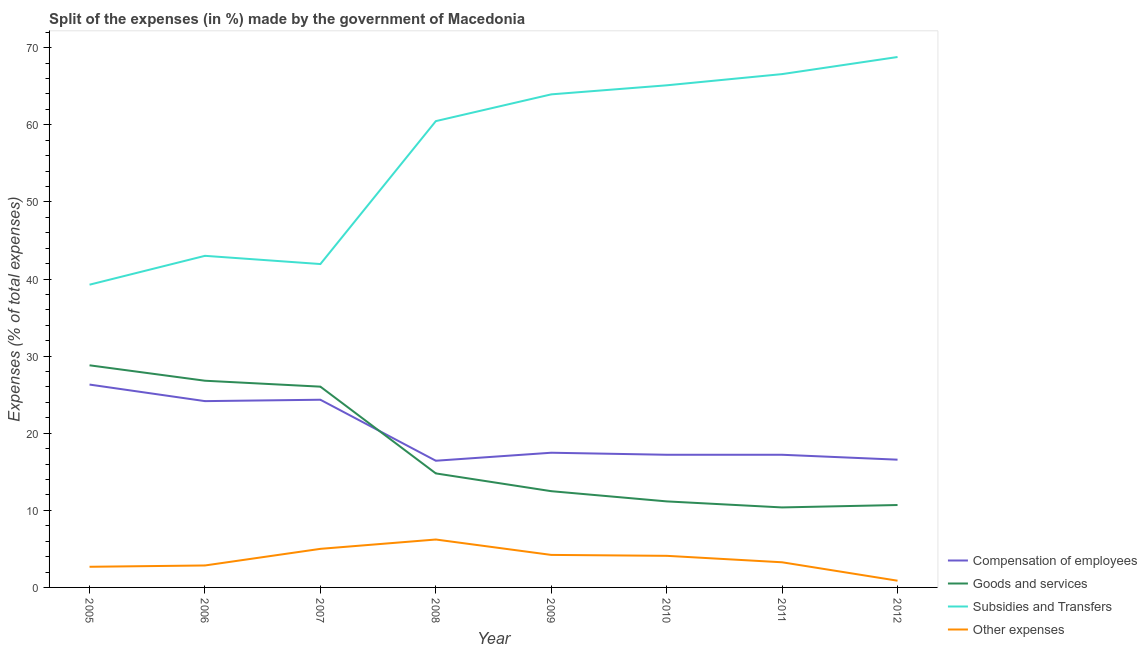How many different coloured lines are there?
Your answer should be very brief. 4. Is the number of lines equal to the number of legend labels?
Keep it short and to the point. Yes. What is the percentage of amount spent on compensation of employees in 2006?
Your answer should be very brief. 24.16. Across all years, what is the maximum percentage of amount spent on goods and services?
Keep it short and to the point. 28.81. Across all years, what is the minimum percentage of amount spent on compensation of employees?
Provide a short and direct response. 16.43. What is the total percentage of amount spent on goods and services in the graph?
Provide a succinct answer. 141.15. What is the difference between the percentage of amount spent on subsidies in 2009 and that in 2011?
Offer a very short reply. -2.63. What is the difference between the percentage of amount spent on compensation of employees in 2007 and the percentage of amount spent on goods and services in 2006?
Offer a terse response. -2.47. What is the average percentage of amount spent on compensation of employees per year?
Offer a very short reply. 19.96. In the year 2008, what is the difference between the percentage of amount spent on goods and services and percentage of amount spent on other expenses?
Give a very brief answer. 8.57. In how many years, is the percentage of amount spent on goods and services greater than 16 %?
Provide a succinct answer. 3. What is the ratio of the percentage of amount spent on subsidies in 2006 to that in 2008?
Your answer should be very brief. 0.71. Is the difference between the percentage of amount spent on goods and services in 2006 and 2012 greater than the difference between the percentage of amount spent on compensation of employees in 2006 and 2012?
Make the answer very short. Yes. What is the difference between the highest and the second highest percentage of amount spent on compensation of employees?
Give a very brief answer. 1.97. What is the difference between the highest and the lowest percentage of amount spent on compensation of employees?
Your answer should be compact. 9.88. Is the sum of the percentage of amount spent on other expenses in 2007 and 2008 greater than the maximum percentage of amount spent on goods and services across all years?
Offer a terse response. No. Is the percentage of amount spent on subsidies strictly less than the percentage of amount spent on goods and services over the years?
Your response must be concise. No. How many years are there in the graph?
Make the answer very short. 8. Are the values on the major ticks of Y-axis written in scientific E-notation?
Make the answer very short. No. Does the graph contain any zero values?
Offer a terse response. No. Does the graph contain grids?
Give a very brief answer. No. How many legend labels are there?
Provide a succinct answer. 4. How are the legend labels stacked?
Provide a short and direct response. Vertical. What is the title of the graph?
Provide a succinct answer. Split of the expenses (in %) made by the government of Macedonia. What is the label or title of the Y-axis?
Keep it short and to the point. Expenses (% of total expenses). What is the Expenses (% of total expenses) of Compensation of employees in 2005?
Your answer should be compact. 26.31. What is the Expenses (% of total expenses) of Goods and services in 2005?
Offer a very short reply. 28.81. What is the Expenses (% of total expenses) of Subsidies and Transfers in 2005?
Your answer should be compact. 39.27. What is the Expenses (% of total expenses) of Other expenses in 2005?
Offer a very short reply. 2.68. What is the Expenses (% of total expenses) of Compensation of employees in 2006?
Provide a succinct answer. 24.16. What is the Expenses (% of total expenses) in Goods and services in 2006?
Give a very brief answer. 26.81. What is the Expenses (% of total expenses) of Subsidies and Transfers in 2006?
Provide a succinct answer. 43.01. What is the Expenses (% of total expenses) in Other expenses in 2006?
Offer a terse response. 2.85. What is the Expenses (% of total expenses) of Compensation of employees in 2007?
Make the answer very short. 24.34. What is the Expenses (% of total expenses) of Goods and services in 2007?
Provide a short and direct response. 26.04. What is the Expenses (% of total expenses) in Subsidies and Transfers in 2007?
Offer a very short reply. 41.94. What is the Expenses (% of total expenses) of Other expenses in 2007?
Offer a very short reply. 5. What is the Expenses (% of total expenses) in Compensation of employees in 2008?
Your response must be concise. 16.43. What is the Expenses (% of total expenses) in Goods and services in 2008?
Your response must be concise. 14.79. What is the Expenses (% of total expenses) in Subsidies and Transfers in 2008?
Your answer should be compact. 60.48. What is the Expenses (% of total expenses) in Other expenses in 2008?
Offer a terse response. 6.21. What is the Expenses (% of total expenses) of Compensation of employees in 2009?
Ensure brevity in your answer.  17.47. What is the Expenses (% of total expenses) in Goods and services in 2009?
Ensure brevity in your answer.  12.48. What is the Expenses (% of total expenses) of Subsidies and Transfers in 2009?
Give a very brief answer. 63.95. What is the Expenses (% of total expenses) in Other expenses in 2009?
Ensure brevity in your answer.  4.22. What is the Expenses (% of total expenses) of Compensation of employees in 2010?
Keep it short and to the point. 17.21. What is the Expenses (% of total expenses) in Goods and services in 2010?
Offer a terse response. 11.16. What is the Expenses (% of total expenses) in Subsidies and Transfers in 2010?
Your answer should be compact. 65.12. What is the Expenses (% of total expenses) of Other expenses in 2010?
Make the answer very short. 4.1. What is the Expenses (% of total expenses) in Compensation of employees in 2011?
Keep it short and to the point. 17.21. What is the Expenses (% of total expenses) in Goods and services in 2011?
Offer a terse response. 10.38. What is the Expenses (% of total expenses) in Subsidies and Transfers in 2011?
Provide a short and direct response. 66.58. What is the Expenses (% of total expenses) in Other expenses in 2011?
Your answer should be very brief. 3.26. What is the Expenses (% of total expenses) in Compensation of employees in 2012?
Your answer should be very brief. 16.57. What is the Expenses (% of total expenses) of Goods and services in 2012?
Give a very brief answer. 10.69. What is the Expenses (% of total expenses) of Subsidies and Transfers in 2012?
Your answer should be very brief. 68.79. What is the Expenses (% of total expenses) of Other expenses in 2012?
Provide a succinct answer. 0.87. Across all years, what is the maximum Expenses (% of total expenses) in Compensation of employees?
Your answer should be compact. 26.31. Across all years, what is the maximum Expenses (% of total expenses) in Goods and services?
Offer a terse response. 28.81. Across all years, what is the maximum Expenses (% of total expenses) in Subsidies and Transfers?
Keep it short and to the point. 68.79. Across all years, what is the maximum Expenses (% of total expenses) in Other expenses?
Your answer should be very brief. 6.21. Across all years, what is the minimum Expenses (% of total expenses) in Compensation of employees?
Provide a succinct answer. 16.43. Across all years, what is the minimum Expenses (% of total expenses) of Goods and services?
Keep it short and to the point. 10.38. Across all years, what is the minimum Expenses (% of total expenses) of Subsidies and Transfers?
Your answer should be very brief. 39.27. Across all years, what is the minimum Expenses (% of total expenses) of Other expenses?
Give a very brief answer. 0.87. What is the total Expenses (% of total expenses) of Compensation of employees in the graph?
Your answer should be compact. 159.7. What is the total Expenses (% of total expenses) of Goods and services in the graph?
Offer a terse response. 141.15. What is the total Expenses (% of total expenses) in Subsidies and Transfers in the graph?
Your answer should be compact. 449.14. What is the total Expenses (% of total expenses) in Other expenses in the graph?
Provide a succinct answer. 29.19. What is the difference between the Expenses (% of total expenses) of Compensation of employees in 2005 and that in 2006?
Your response must be concise. 2.15. What is the difference between the Expenses (% of total expenses) in Goods and services in 2005 and that in 2006?
Your response must be concise. 2. What is the difference between the Expenses (% of total expenses) of Subsidies and Transfers in 2005 and that in 2006?
Provide a short and direct response. -3.74. What is the difference between the Expenses (% of total expenses) of Other expenses in 2005 and that in 2006?
Give a very brief answer. -0.17. What is the difference between the Expenses (% of total expenses) in Compensation of employees in 2005 and that in 2007?
Offer a very short reply. 1.97. What is the difference between the Expenses (% of total expenses) of Goods and services in 2005 and that in 2007?
Make the answer very short. 2.77. What is the difference between the Expenses (% of total expenses) in Subsidies and Transfers in 2005 and that in 2007?
Make the answer very short. -2.68. What is the difference between the Expenses (% of total expenses) of Other expenses in 2005 and that in 2007?
Give a very brief answer. -2.33. What is the difference between the Expenses (% of total expenses) in Compensation of employees in 2005 and that in 2008?
Make the answer very short. 9.88. What is the difference between the Expenses (% of total expenses) of Goods and services in 2005 and that in 2008?
Provide a short and direct response. 14.02. What is the difference between the Expenses (% of total expenses) in Subsidies and Transfers in 2005 and that in 2008?
Your answer should be very brief. -21.21. What is the difference between the Expenses (% of total expenses) of Other expenses in 2005 and that in 2008?
Offer a very short reply. -3.54. What is the difference between the Expenses (% of total expenses) of Compensation of employees in 2005 and that in 2009?
Keep it short and to the point. 8.84. What is the difference between the Expenses (% of total expenses) in Goods and services in 2005 and that in 2009?
Offer a very short reply. 16.33. What is the difference between the Expenses (% of total expenses) of Subsidies and Transfers in 2005 and that in 2009?
Ensure brevity in your answer.  -24.68. What is the difference between the Expenses (% of total expenses) of Other expenses in 2005 and that in 2009?
Offer a terse response. -1.54. What is the difference between the Expenses (% of total expenses) of Compensation of employees in 2005 and that in 2010?
Your response must be concise. 9.1. What is the difference between the Expenses (% of total expenses) of Goods and services in 2005 and that in 2010?
Keep it short and to the point. 17.65. What is the difference between the Expenses (% of total expenses) in Subsidies and Transfers in 2005 and that in 2010?
Your response must be concise. -25.86. What is the difference between the Expenses (% of total expenses) in Other expenses in 2005 and that in 2010?
Give a very brief answer. -1.42. What is the difference between the Expenses (% of total expenses) in Compensation of employees in 2005 and that in 2011?
Your answer should be very brief. 9.1. What is the difference between the Expenses (% of total expenses) of Goods and services in 2005 and that in 2011?
Provide a short and direct response. 18.43. What is the difference between the Expenses (% of total expenses) in Subsidies and Transfers in 2005 and that in 2011?
Keep it short and to the point. -27.31. What is the difference between the Expenses (% of total expenses) in Other expenses in 2005 and that in 2011?
Keep it short and to the point. -0.58. What is the difference between the Expenses (% of total expenses) in Compensation of employees in 2005 and that in 2012?
Ensure brevity in your answer.  9.74. What is the difference between the Expenses (% of total expenses) in Goods and services in 2005 and that in 2012?
Give a very brief answer. 18.12. What is the difference between the Expenses (% of total expenses) of Subsidies and Transfers in 2005 and that in 2012?
Offer a terse response. -29.53. What is the difference between the Expenses (% of total expenses) of Other expenses in 2005 and that in 2012?
Keep it short and to the point. 1.8. What is the difference between the Expenses (% of total expenses) in Compensation of employees in 2006 and that in 2007?
Give a very brief answer. -0.18. What is the difference between the Expenses (% of total expenses) of Goods and services in 2006 and that in 2007?
Your answer should be very brief. 0.77. What is the difference between the Expenses (% of total expenses) of Subsidies and Transfers in 2006 and that in 2007?
Your answer should be compact. 1.07. What is the difference between the Expenses (% of total expenses) of Other expenses in 2006 and that in 2007?
Make the answer very short. -2.16. What is the difference between the Expenses (% of total expenses) of Compensation of employees in 2006 and that in 2008?
Provide a short and direct response. 7.73. What is the difference between the Expenses (% of total expenses) of Goods and services in 2006 and that in 2008?
Ensure brevity in your answer.  12.02. What is the difference between the Expenses (% of total expenses) of Subsidies and Transfers in 2006 and that in 2008?
Make the answer very short. -17.47. What is the difference between the Expenses (% of total expenses) of Other expenses in 2006 and that in 2008?
Keep it short and to the point. -3.37. What is the difference between the Expenses (% of total expenses) in Compensation of employees in 2006 and that in 2009?
Ensure brevity in your answer.  6.69. What is the difference between the Expenses (% of total expenses) in Goods and services in 2006 and that in 2009?
Provide a succinct answer. 14.33. What is the difference between the Expenses (% of total expenses) in Subsidies and Transfers in 2006 and that in 2009?
Offer a very short reply. -20.94. What is the difference between the Expenses (% of total expenses) of Other expenses in 2006 and that in 2009?
Ensure brevity in your answer.  -1.37. What is the difference between the Expenses (% of total expenses) in Compensation of employees in 2006 and that in 2010?
Give a very brief answer. 6.96. What is the difference between the Expenses (% of total expenses) of Goods and services in 2006 and that in 2010?
Make the answer very short. 15.65. What is the difference between the Expenses (% of total expenses) of Subsidies and Transfers in 2006 and that in 2010?
Give a very brief answer. -22.11. What is the difference between the Expenses (% of total expenses) of Other expenses in 2006 and that in 2010?
Your response must be concise. -1.25. What is the difference between the Expenses (% of total expenses) in Compensation of employees in 2006 and that in 2011?
Provide a succinct answer. 6.96. What is the difference between the Expenses (% of total expenses) in Goods and services in 2006 and that in 2011?
Give a very brief answer. 16.43. What is the difference between the Expenses (% of total expenses) of Subsidies and Transfers in 2006 and that in 2011?
Provide a succinct answer. -23.57. What is the difference between the Expenses (% of total expenses) in Other expenses in 2006 and that in 2011?
Offer a very short reply. -0.41. What is the difference between the Expenses (% of total expenses) of Compensation of employees in 2006 and that in 2012?
Your answer should be compact. 7.59. What is the difference between the Expenses (% of total expenses) in Goods and services in 2006 and that in 2012?
Provide a succinct answer. 16.12. What is the difference between the Expenses (% of total expenses) of Subsidies and Transfers in 2006 and that in 2012?
Keep it short and to the point. -25.79. What is the difference between the Expenses (% of total expenses) in Other expenses in 2006 and that in 2012?
Your response must be concise. 1.98. What is the difference between the Expenses (% of total expenses) in Compensation of employees in 2007 and that in 2008?
Provide a short and direct response. 7.91. What is the difference between the Expenses (% of total expenses) in Goods and services in 2007 and that in 2008?
Give a very brief answer. 11.25. What is the difference between the Expenses (% of total expenses) of Subsidies and Transfers in 2007 and that in 2008?
Keep it short and to the point. -18.54. What is the difference between the Expenses (% of total expenses) in Other expenses in 2007 and that in 2008?
Keep it short and to the point. -1.21. What is the difference between the Expenses (% of total expenses) in Compensation of employees in 2007 and that in 2009?
Keep it short and to the point. 6.87. What is the difference between the Expenses (% of total expenses) of Goods and services in 2007 and that in 2009?
Provide a succinct answer. 13.56. What is the difference between the Expenses (% of total expenses) in Subsidies and Transfers in 2007 and that in 2009?
Offer a very short reply. -22.01. What is the difference between the Expenses (% of total expenses) of Other expenses in 2007 and that in 2009?
Provide a short and direct response. 0.79. What is the difference between the Expenses (% of total expenses) in Compensation of employees in 2007 and that in 2010?
Your answer should be very brief. 7.14. What is the difference between the Expenses (% of total expenses) in Goods and services in 2007 and that in 2010?
Your answer should be very brief. 14.88. What is the difference between the Expenses (% of total expenses) in Subsidies and Transfers in 2007 and that in 2010?
Ensure brevity in your answer.  -23.18. What is the difference between the Expenses (% of total expenses) in Other expenses in 2007 and that in 2010?
Keep it short and to the point. 0.9. What is the difference between the Expenses (% of total expenses) of Compensation of employees in 2007 and that in 2011?
Keep it short and to the point. 7.14. What is the difference between the Expenses (% of total expenses) of Goods and services in 2007 and that in 2011?
Provide a short and direct response. 15.66. What is the difference between the Expenses (% of total expenses) in Subsidies and Transfers in 2007 and that in 2011?
Give a very brief answer. -24.63. What is the difference between the Expenses (% of total expenses) of Other expenses in 2007 and that in 2011?
Provide a short and direct response. 1.74. What is the difference between the Expenses (% of total expenses) of Compensation of employees in 2007 and that in 2012?
Make the answer very short. 7.77. What is the difference between the Expenses (% of total expenses) in Goods and services in 2007 and that in 2012?
Offer a very short reply. 15.35. What is the difference between the Expenses (% of total expenses) of Subsidies and Transfers in 2007 and that in 2012?
Provide a short and direct response. -26.85. What is the difference between the Expenses (% of total expenses) in Other expenses in 2007 and that in 2012?
Provide a succinct answer. 4.13. What is the difference between the Expenses (% of total expenses) in Compensation of employees in 2008 and that in 2009?
Your answer should be compact. -1.04. What is the difference between the Expenses (% of total expenses) of Goods and services in 2008 and that in 2009?
Your answer should be compact. 2.31. What is the difference between the Expenses (% of total expenses) in Subsidies and Transfers in 2008 and that in 2009?
Give a very brief answer. -3.47. What is the difference between the Expenses (% of total expenses) in Other expenses in 2008 and that in 2009?
Offer a terse response. 2. What is the difference between the Expenses (% of total expenses) of Compensation of employees in 2008 and that in 2010?
Ensure brevity in your answer.  -0.78. What is the difference between the Expenses (% of total expenses) of Goods and services in 2008 and that in 2010?
Offer a very short reply. 3.63. What is the difference between the Expenses (% of total expenses) of Subsidies and Transfers in 2008 and that in 2010?
Your answer should be compact. -4.64. What is the difference between the Expenses (% of total expenses) in Other expenses in 2008 and that in 2010?
Give a very brief answer. 2.12. What is the difference between the Expenses (% of total expenses) of Compensation of employees in 2008 and that in 2011?
Your answer should be compact. -0.77. What is the difference between the Expenses (% of total expenses) in Goods and services in 2008 and that in 2011?
Give a very brief answer. 4.41. What is the difference between the Expenses (% of total expenses) of Subsidies and Transfers in 2008 and that in 2011?
Make the answer very short. -6.1. What is the difference between the Expenses (% of total expenses) in Other expenses in 2008 and that in 2011?
Give a very brief answer. 2.95. What is the difference between the Expenses (% of total expenses) of Compensation of employees in 2008 and that in 2012?
Offer a very short reply. -0.14. What is the difference between the Expenses (% of total expenses) of Goods and services in 2008 and that in 2012?
Ensure brevity in your answer.  4.1. What is the difference between the Expenses (% of total expenses) in Subsidies and Transfers in 2008 and that in 2012?
Offer a terse response. -8.32. What is the difference between the Expenses (% of total expenses) in Other expenses in 2008 and that in 2012?
Your response must be concise. 5.34. What is the difference between the Expenses (% of total expenses) of Compensation of employees in 2009 and that in 2010?
Your answer should be compact. 0.26. What is the difference between the Expenses (% of total expenses) of Goods and services in 2009 and that in 2010?
Your response must be concise. 1.32. What is the difference between the Expenses (% of total expenses) in Subsidies and Transfers in 2009 and that in 2010?
Make the answer very short. -1.17. What is the difference between the Expenses (% of total expenses) in Other expenses in 2009 and that in 2010?
Give a very brief answer. 0.12. What is the difference between the Expenses (% of total expenses) in Compensation of employees in 2009 and that in 2011?
Ensure brevity in your answer.  0.26. What is the difference between the Expenses (% of total expenses) of Goods and services in 2009 and that in 2011?
Offer a very short reply. 2.11. What is the difference between the Expenses (% of total expenses) of Subsidies and Transfers in 2009 and that in 2011?
Offer a very short reply. -2.63. What is the difference between the Expenses (% of total expenses) in Other expenses in 2009 and that in 2011?
Offer a terse response. 0.96. What is the difference between the Expenses (% of total expenses) of Compensation of employees in 2009 and that in 2012?
Ensure brevity in your answer.  0.9. What is the difference between the Expenses (% of total expenses) of Goods and services in 2009 and that in 2012?
Make the answer very short. 1.79. What is the difference between the Expenses (% of total expenses) in Subsidies and Transfers in 2009 and that in 2012?
Offer a very short reply. -4.84. What is the difference between the Expenses (% of total expenses) of Other expenses in 2009 and that in 2012?
Your answer should be compact. 3.34. What is the difference between the Expenses (% of total expenses) in Compensation of employees in 2010 and that in 2011?
Provide a succinct answer. 0. What is the difference between the Expenses (% of total expenses) of Goods and services in 2010 and that in 2011?
Provide a succinct answer. 0.78. What is the difference between the Expenses (% of total expenses) in Subsidies and Transfers in 2010 and that in 2011?
Make the answer very short. -1.45. What is the difference between the Expenses (% of total expenses) in Other expenses in 2010 and that in 2011?
Your answer should be compact. 0.84. What is the difference between the Expenses (% of total expenses) of Compensation of employees in 2010 and that in 2012?
Keep it short and to the point. 0.64. What is the difference between the Expenses (% of total expenses) in Goods and services in 2010 and that in 2012?
Ensure brevity in your answer.  0.47. What is the difference between the Expenses (% of total expenses) of Subsidies and Transfers in 2010 and that in 2012?
Your answer should be compact. -3.67. What is the difference between the Expenses (% of total expenses) in Other expenses in 2010 and that in 2012?
Offer a very short reply. 3.23. What is the difference between the Expenses (% of total expenses) in Compensation of employees in 2011 and that in 2012?
Your answer should be very brief. 0.64. What is the difference between the Expenses (% of total expenses) in Goods and services in 2011 and that in 2012?
Your response must be concise. -0.31. What is the difference between the Expenses (% of total expenses) of Subsidies and Transfers in 2011 and that in 2012?
Ensure brevity in your answer.  -2.22. What is the difference between the Expenses (% of total expenses) of Other expenses in 2011 and that in 2012?
Offer a terse response. 2.39. What is the difference between the Expenses (% of total expenses) in Compensation of employees in 2005 and the Expenses (% of total expenses) in Goods and services in 2006?
Give a very brief answer. -0.5. What is the difference between the Expenses (% of total expenses) of Compensation of employees in 2005 and the Expenses (% of total expenses) of Subsidies and Transfers in 2006?
Offer a terse response. -16.7. What is the difference between the Expenses (% of total expenses) of Compensation of employees in 2005 and the Expenses (% of total expenses) of Other expenses in 2006?
Give a very brief answer. 23.46. What is the difference between the Expenses (% of total expenses) in Goods and services in 2005 and the Expenses (% of total expenses) in Subsidies and Transfers in 2006?
Make the answer very short. -14.2. What is the difference between the Expenses (% of total expenses) in Goods and services in 2005 and the Expenses (% of total expenses) in Other expenses in 2006?
Make the answer very short. 25.96. What is the difference between the Expenses (% of total expenses) of Subsidies and Transfers in 2005 and the Expenses (% of total expenses) of Other expenses in 2006?
Your answer should be very brief. 36.42. What is the difference between the Expenses (% of total expenses) of Compensation of employees in 2005 and the Expenses (% of total expenses) of Goods and services in 2007?
Your answer should be compact. 0.27. What is the difference between the Expenses (% of total expenses) in Compensation of employees in 2005 and the Expenses (% of total expenses) in Subsidies and Transfers in 2007?
Your answer should be compact. -15.63. What is the difference between the Expenses (% of total expenses) in Compensation of employees in 2005 and the Expenses (% of total expenses) in Other expenses in 2007?
Provide a short and direct response. 21.31. What is the difference between the Expenses (% of total expenses) in Goods and services in 2005 and the Expenses (% of total expenses) in Subsidies and Transfers in 2007?
Offer a very short reply. -13.13. What is the difference between the Expenses (% of total expenses) in Goods and services in 2005 and the Expenses (% of total expenses) in Other expenses in 2007?
Keep it short and to the point. 23.8. What is the difference between the Expenses (% of total expenses) of Subsidies and Transfers in 2005 and the Expenses (% of total expenses) of Other expenses in 2007?
Offer a very short reply. 34.26. What is the difference between the Expenses (% of total expenses) in Compensation of employees in 2005 and the Expenses (% of total expenses) in Goods and services in 2008?
Keep it short and to the point. 11.52. What is the difference between the Expenses (% of total expenses) of Compensation of employees in 2005 and the Expenses (% of total expenses) of Subsidies and Transfers in 2008?
Provide a short and direct response. -34.17. What is the difference between the Expenses (% of total expenses) in Compensation of employees in 2005 and the Expenses (% of total expenses) in Other expenses in 2008?
Your answer should be very brief. 20.1. What is the difference between the Expenses (% of total expenses) in Goods and services in 2005 and the Expenses (% of total expenses) in Subsidies and Transfers in 2008?
Ensure brevity in your answer.  -31.67. What is the difference between the Expenses (% of total expenses) in Goods and services in 2005 and the Expenses (% of total expenses) in Other expenses in 2008?
Provide a short and direct response. 22.59. What is the difference between the Expenses (% of total expenses) of Subsidies and Transfers in 2005 and the Expenses (% of total expenses) of Other expenses in 2008?
Your response must be concise. 33.05. What is the difference between the Expenses (% of total expenses) of Compensation of employees in 2005 and the Expenses (% of total expenses) of Goods and services in 2009?
Provide a short and direct response. 13.83. What is the difference between the Expenses (% of total expenses) in Compensation of employees in 2005 and the Expenses (% of total expenses) in Subsidies and Transfers in 2009?
Make the answer very short. -37.64. What is the difference between the Expenses (% of total expenses) in Compensation of employees in 2005 and the Expenses (% of total expenses) in Other expenses in 2009?
Make the answer very short. 22.09. What is the difference between the Expenses (% of total expenses) in Goods and services in 2005 and the Expenses (% of total expenses) in Subsidies and Transfers in 2009?
Offer a terse response. -35.14. What is the difference between the Expenses (% of total expenses) of Goods and services in 2005 and the Expenses (% of total expenses) of Other expenses in 2009?
Your answer should be very brief. 24.59. What is the difference between the Expenses (% of total expenses) of Subsidies and Transfers in 2005 and the Expenses (% of total expenses) of Other expenses in 2009?
Provide a short and direct response. 35.05. What is the difference between the Expenses (% of total expenses) of Compensation of employees in 2005 and the Expenses (% of total expenses) of Goods and services in 2010?
Your response must be concise. 15.15. What is the difference between the Expenses (% of total expenses) of Compensation of employees in 2005 and the Expenses (% of total expenses) of Subsidies and Transfers in 2010?
Make the answer very short. -38.81. What is the difference between the Expenses (% of total expenses) of Compensation of employees in 2005 and the Expenses (% of total expenses) of Other expenses in 2010?
Ensure brevity in your answer.  22.21. What is the difference between the Expenses (% of total expenses) of Goods and services in 2005 and the Expenses (% of total expenses) of Subsidies and Transfers in 2010?
Make the answer very short. -36.31. What is the difference between the Expenses (% of total expenses) of Goods and services in 2005 and the Expenses (% of total expenses) of Other expenses in 2010?
Your response must be concise. 24.71. What is the difference between the Expenses (% of total expenses) of Subsidies and Transfers in 2005 and the Expenses (% of total expenses) of Other expenses in 2010?
Give a very brief answer. 35.17. What is the difference between the Expenses (% of total expenses) in Compensation of employees in 2005 and the Expenses (% of total expenses) in Goods and services in 2011?
Your response must be concise. 15.93. What is the difference between the Expenses (% of total expenses) in Compensation of employees in 2005 and the Expenses (% of total expenses) in Subsidies and Transfers in 2011?
Provide a short and direct response. -40.27. What is the difference between the Expenses (% of total expenses) in Compensation of employees in 2005 and the Expenses (% of total expenses) in Other expenses in 2011?
Keep it short and to the point. 23.05. What is the difference between the Expenses (% of total expenses) in Goods and services in 2005 and the Expenses (% of total expenses) in Subsidies and Transfers in 2011?
Ensure brevity in your answer.  -37.77. What is the difference between the Expenses (% of total expenses) in Goods and services in 2005 and the Expenses (% of total expenses) in Other expenses in 2011?
Your answer should be compact. 25.55. What is the difference between the Expenses (% of total expenses) in Subsidies and Transfers in 2005 and the Expenses (% of total expenses) in Other expenses in 2011?
Your answer should be very brief. 36. What is the difference between the Expenses (% of total expenses) of Compensation of employees in 2005 and the Expenses (% of total expenses) of Goods and services in 2012?
Your response must be concise. 15.62. What is the difference between the Expenses (% of total expenses) of Compensation of employees in 2005 and the Expenses (% of total expenses) of Subsidies and Transfers in 2012?
Your answer should be compact. -42.48. What is the difference between the Expenses (% of total expenses) in Compensation of employees in 2005 and the Expenses (% of total expenses) in Other expenses in 2012?
Ensure brevity in your answer.  25.44. What is the difference between the Expenses (% of total expenses) in Goods and services in 2005 and the Expenses (% of total expenses) in Subsidies and Transfers in 2012?
Your answer should be very brief. -39.99. What is the difference between the Expenses (% of total expenses) in Goods and services in 2005 and the Expenses (% of total expenses) in Other expenses in 2012?
Offer a very short reply. 27.94. What is the difference between the Expenses (% of total expenses) of Subsidies and Transfers in 2005 and the Expenses (% of total expenses) of Other expenses in 2012?
Give a very brief answer. 38.39. What is the difference between the Expenses (% of total expenses) in Compensation of employees in 2006 and the Expenses (% of total expenses) in Goods and services in 2007?
Offer a very short reply. -1.88. What is the difference between the Expenses (% of total expenses) of Compensation of employees in 2006 and the Expenses (% of total expenses) of Subsidies and Transfers in 2007?
Make the answer very short. -17.78. What is the difference between the Expenses (% of total expenses) of Compensation of employees in 2006 and the Expenses (% of total expenses) of Other expenses in 2007?
Your answer should be compact. 19.16. What is the difference between the Expenses (% of total expenses) in Goods and services in 2006 and the Expenses (% of total expenses) in Subsidies and Transfers in 2007?
Provide a succinct answer. -15.13. What is the difference between the Expenses (% of total expenses) of Goods and services in 2006 and the Expenses (% of total expenses) of Other expenses in 2007?
Keep it short and to the point. 21.8. What is the difference between the Expenses (% of total expenses) in Subsidies and Transfers in 2006 and the Expenses (% of total expenses) in Other expenses in 2007?
Your answer should be very brief. 38. What is the difference between the Expenses (% of total expenses) of Compensation of employees in 2006 and the Expenses (% of total expenses) of Goods and services in 2008?
Your response must be concise. 9.37. What is the difference between the Expenses (% of total expenses) in Compensation of employees in 2006 and the Expenses (% of total expenses) in Subsidies and Transfers in 2008?
Your response must be concise. -36.32. What is the difference between the Expenses (% of total expenses) of Compensation of employees in 2006 and the Expenses (% of total expenses) of Other expenses in 2008?
Offer a very short reply. 17.95. What is the difference between the Expenses (% of total expenses) of Goods and services in 2006 and the Expenses (% of total expenses) of Subsidies and Transfers in 2008?
Offer a very short reply. -33.67. What is the difference between the Expenses (% of total expenses) in Goods and services in 2006 and the Expenses (% of total expenses) in Other expenses in 2008?
Offer a terse response. 20.59. What is the difference between the Expenses (% of total expenses) of Subsidies and Transfers in 2006 and the Expenses (% of total expenses) of Other expenses in 2008?
Provide a succinct answer. 36.79. What is the difference between the Expenses (% of total expenses) of Compensation of employees in 2006 and the Expenses (% of total expenses) of Goods and services in 2009?
Keep it short and to the point. 11.68. What is the difference between the Expenses (% of total expenses) of Compensation of employees in 2006 and the Expenses (% of total expenses) of Subsidies and Transfers in 2009?
Your response must be concise. -39.79. What is the difference between the Expenses (% of total expenses) of Compensation of employees in 2006 and the Expenses (% of total expenses) of Other expenses in 2009?
Your answer should be compact. 19.95. What is the difference between the Expenses (% of total expenses) of Goods and services in 2006 and the Expenses (% of total expenses) of Subsidies and Transfers in 2009?
Your response must be concise. -37.14. What is the difference between the Expenses (% of total expenses) of Goods and services in 2006 and the Expenses (% of total expenses) of Other expenses in 2009?
Ensure brevity in your answer.  22.59. What is the difference between the Expenses (% of total expenses) of Subsidies and Transfers in 2006 and the Expenses (% of total expenses) of Other expenses in 2009?
Provide a short and direct response. 38.79. What is the difference between the Expenses (% of total expenses) of Compensation of employees in 2006 and the Expenses (% of total expenses) of Goods and services in 2010?
Keep it short and to the point. 13. What is the difference between the Expenses (% of total expenses) of Compensation of employees in 2006 and the Expenses (% of total expenses) of Subsidies and Transfers in 2010?
Ensure brevity in your answer.  -40.96. What is the difference between the Expenses (% of total expenses) in Compensation of employees in 2006 and the Expenses (% of total expenses) in Other expenses in 2010?
Provide a short and direct response. 20.06. What is the difference between the Expenses (% of total expenses) of Goods and services in 2006 and the Expenses (% of total expenses) of Subsidies and Transfers in 2010?
Your response must be concise. -38.31. What is the difference between the Expenses (% of total expenses) in Goods and services in 2006 and the Expenses (% of total expenses) in Other expenses in 2010?
Offer a terse response. 22.71. What is the difference between the Expenses (% of total expenses) of Subsidies and Transfers in 2006 and the Expenses (% of total expenses) of Other expenses in 2010?
Offer a terse response. 38.91. What is the difference between the Expenses (% of total expenses) in Compensation of employees in 2006 and the Expenses (% of total expenses) in Goods and services in 2011?
Your answer should be compact. 13.79. What is the difference between the Expenses (% of total expenses) in Compensation of employees in 2006 and the Expenses (% of total expenses) in Subsidies and Transfers in 2011?
Give a very brief answer. -42.41. What is the difference between the Expenses (% of total expenses) in Compensation of employees in 2006 and the Expenses (% of total expenses) in Other expenses in 2011?
Offer a terse response. 20.9. What is the difference between the Expenses (% of total expenses) of Goods and services in 2006 and the Expenses (% of total expenses) of Subsidies and Transfers in 2011?
Give a very brief answer. -39.77. What is the difference between the Expenses (% of total expenses) of Goods and services in 2006 and the Expenses (% of total expenses) of Other expenses in 2011?
Keep it short and to the point. 23.55. What is the difference between the Expenses (% of total expenses) of Subsidies and Transfers in 2006 and the Expenses (% of total expenses) of Other expenses in 2011?
Offer a terse response. 39.75. What is the difference between the Expenses (% of total expenses) of Compensation of employees in 2006 and the Expenses (% of total expenses) of Goods and services in 2012?
Provide a short and direct response. 13.47. What is the difference between the Expenses (% of total expenses) in Compensation of employees in 2006 and the Expenses (% of total expenses) in Subsidies and Transfers in 2012?
Give a very brief answer. -44.63. What is the difference between the Expenses (% of total expenses) of Compensation of employees in 2006 and the Expenses (% of total expenses) of Other expenses in 2012?
Provide a succinct answer. 23.29. What is the difference between the Expenses (% of total expenses) of Goods and services in 2006 and the Expenses (% of total expenses) of Subsidies and Transfers in 2012?
Your answer should be compact. -41.99. What is the difference between the Expenses (% of total expenses) in Goods and services in 2006 and the Expenses (% of total expenses) in Other expenses in 2012?
Your answer should be compact. 25.94. What is the difference between the Expenses (% of total expenses) of Subsidies and Transfers in 2006 and the Expenses (% of total expenses) of Other expenses in 2012?
Provide a succinct answer. 42.14. What is the difference between the Expenses (% of total expenses) of Compensation of employees in 2007 and the Expenses (% of total expenses) of Goods and services in 2008?
Ensure brevity in your answer.  9.55. What is the difference between the Expenses (% of total expenses) of Compensation of employees in 2007 and the Expenses (% of total expenses) of Subsidies and Transfers in 2008?
Ensure brevity in your answer.  -36.14. What is the difference between the Expenses (% of total expenses) of Compensation of employees in 2007 and the Expenses (% of total expenses) of Other expenses in 2008?
Ensure brevity in your answer.  18.13. What is the difference between the Expenses (% of total expenses) in Goods and services in 2007 and the Expenses (% of total expenses) in Subsidies and Transfers in 2008?
Make the answer very short. -34.44. What is the difference between the Expenses (% of total expenses) in Goods and services in 2007 and the Expenses (% of total expenses) in Other expenses in 2008?
Ensure brevity in your answer.  19.83. What is the difference between the Expenses (% of total expenses) of Subsidies and Transfers in 2007 and the Expenses (% of total expenses) of Other expenses in 2008?
Your answer should be compact. 35.73. What is the difference between the Expenses (% of total expenses) of Compensation of employees in 2007 and the Expenses (% of total expenses) of Goods and services in 2009?
Provide a succinct answer. 11.86. What is the difference between the Expenses (% of total expenses) in Compensation of employees in 2007 and the Expenses (% of total expenses) in Subsidies and Transfers in 2009?
Your response must be concise. -39.61. What is the difference between the Expenses (% of total expenses) of Compensation of employees in 2007 and the Expenses (% of total expenses) of Other expenses in 2009?
Your answer should be compact. 20.13. What is the difference between the Expenses (% of total expenses) in Goods and services in 2007 and the Expenses (% of total expenses) in Subsidies and Transfers in 2009?
Your answer should be very brief. -37.91. What is the difference between the Expenses (% of total expenses) of Goods and services in 2007 and the Expenses (% of total expenses) of Other expenses in 2009?
Offer a terse response. 21.82. What is the difference between the Expenses (% of total expenses) in Subsidies and Transfers in 2007 and the Expenses (% of total expenses) in Other expenses in 2009?
Give a very brief answer. 37.73. What is the difference between the Expenses (% of total expenses) of Compensation of employees in 2007 and the Expenses (% of total expenses) of Goods and services in 2010?
Ensure brevity in your answer.  13.18. What is the difference between the Expenses (% of total expenses) in Compensation of employees in 2007 and the Expenses (% of total expenses) in Subsidies and Transfers in 2010?
Provide a short and direct response. -40.78. What is the difference between the Expenses (% of total expenses) of Compensation of employees in 2007 and the Expenses (% of total expenses) of Other expenses in 2010?
Offer a very short reply. 20.24. What is the difference between the Expenses (% of total expenses) of Goods and services in 2007 and the Expenses (% of total expenses) of Subsidies and Transfers in 2010?
Provide a short and direct response. -39.08. What is the difference between the Expenses (% of total expenses) in Goods and services in 2007 and the Expenses (% of total expenses) in Other expenses in 2010?
Keep it short and to the point. 21.94. What is the difference between the Expenses (% of total expenses) in Subsidies and Transfers in 2007 and the Expenses (% of total expenses) in Other expenses in 2010?
Your response must be concise. 37.84. What is the difference between the Expenses (% of total expenses) of Compensation of employees in 2007 and the Expenses (% of total expenses) of Goods and services in 2011?
Offer a very short reply. 13.97. What is the difference between the Expenses (% of total expenses) in Compensation of employees in 2007 and the Expenses (% of total expenses) in Subsidies and Transfers in 2011?
Give a very brief answer. -42.23. What is the difference between the Expenses (% of total expenses) in Compensation of employees in 2007 and the Expenses (% of total expenses) in Other expenses in 2011?
Offer a terse response. 21.08. What is the difference between the Expenses (% of total expenses) in Goods and services in 2007 and the Expenses (% of total expenses) in Subsidies and Transfers in 2011?
Offer a very short reply. -40.54. What is the difference between the Expenses (% of total expenses) in Goods and services in 2007 and the Expenses (% of total expenses) in Other expenses in 2011?
Provide a short and direct response. 22.78. What is the difference between the Expenses (% of total expenses) of Subsidies and Transfers in 2007 and the Expenses (% of total expenses) of Other expenses in 2011?
Offer a very short reply. 38.68. What is the difference between the Expenses (% of total expenses) of Compensation of employees in 2007 and the Expenses (% of total expenses) of Goods and services in 2012?
Ensure brevity in your answer.  13.65. What is the difference between the Expenses (% of total expenses) of Compensation of employees in 2007 and the Expenses (% of total expenses) of Subsidies and Transfers in 2012?
Make the answer very short. -44.45. What is the difference between the Expenses (% of total expenses) in Compensation of employees in 2007 and the Expenses (% of total expenses) in Other expenses in 2012?
Give a very brief answer. 23.47. What is the difference between the Expenses (% of total expenses) of Goods and services in 2007 and the Expenses (% of total expenses) of Subsidies and Transfers in 2012?
Provide a short and direct response. -42.75. What is the difference between the Expenses (% of total expenses) in Goods and services in 2007 and the Expenses (% of total expenses) in Other expenses in 2012?
Your answer should be compact. 25.17. What is the difference between the Expenses (% of total expenses) in Subsidies and Transfers in 2007 and the Expenses (% of total expenses) in Other expenses in 2012?
Offer a terse response. 41.07. What is the difference between the Expenses (% of total expenses) of Compensation of employees in 2008 and the Expenses (% of total expenses) of Goods and services in 2009?
Offer a very short reply. 3.95. What is the difference between the Expenses (% of total expenses) in Compensation of employees in 2008 and the Expenses (% of total expenses) in Subsidies and Transfers in 2009?
Offer a very short reply. -47.52. What is the difference between the Expenses (% of total expenses) of Compensation of employees in 2008 and the Expenses (% of total expenses) of Other expenses in 2009?
Offer a very short reply. 12.21. What is the difference between the Expenses (% of total expenses) in Goods and services in 2008 and the Expenses (% of total expenses) in Subsidies and Transfers in 2009?
Your answer should be very brief. -49.16. What is the difference between the Expenses (% of total expenses) in Goods and services in 2008 and the Expenses (% of total expenses) in Other expenses in 2009?
Provide a short and direct response. 10.57. What is the difference between the Expenses (% of total expenses) of Subsidies and Transfers in 2008 and the Expenses (% of total expenses) of Other expenses in 2009?
Your response must be concise. 56.26. What is the difference between the Expenses (% of total expenses) of Compensation of employees in 2008 and the Expenses (% of total expenses) of Goods and services in 2010?
Keep it short and to the point. 5.27. What is the difference between the Expenses (% of total expenses) in Compensation of employees in 2008 and the Expenses (% of total expenses) in Subsidies and Transfers in 2010?
Give a very brief answer. -48.69. What is the difference between the Expenses (% of total expenses) of Compensation of employees in 2008 and the Expenses (% of total expenses) of Other expenses in 2010?
Provide a succinct answer. 12.33. What is the difference between the Expenses (% of total expenses) of Goods and services in 2008 and the Expenses (% of total expenses) of Subsidies and Transfers in 2010?
Your answer should be very brief. -50.33. What is the difference between the Expenses (% of total expenses) of Goods and services in 2008 and the Expenses (% of total expenses) of Other expenses in 2010?
Offer a terse response. 10.69. What is the difference between the Expenses (% of total expenses) of Subsidies and Transfers in 2008 and the Expenses (% of total expenses) of Other expenses in 2010?
Provide a short and direct response. 56.38. What is the difference between the Expenses (% of total expenses) in Compensation of employees in 2008 and the Expenses (% of total expenses) in Goods and services in 2011?
Provide a succinct answer. 6.06. What is the difference between the Expenses (% of total expenses) of Compensation of employees in 2008 and the Expenses (% of total expenses) of Subsidies and Transfers in 2011?
Ensure brevity in your answer.  -50.15. What is the difference between the Expenses (% of total expenses) of Compensation of employees in 2008 and the Expenses (% of total expenses) of Other expenses in 2011?
Ensure brevity in your answer.  13.17. What is the difference between the Expenses (% of total expenses) in Goods and services in 2008 and the Expenses (% of total expenses) in Subsidies and Transfers in 2011?
Your answer should be compact. -51.79. What is the difference between the Expenses (% of total expenses) of Goods and services in 2008 and the Expenses (% of total expenses) of Other expenses in 2011?
Your response must be concise. 11.53. What is the difference between the Expenses (% of total expenses) in Subsidies and Transfers in 2008 and the Expenses (% of total expenses) in Other expenses in 2011?
Your response must be concise. 57.22. What is the difference between the Expenses (% of total expenses) of Compensation of employees in 2008 and the Expenses (% of total expenses) of Goods and services in 2012?
Your answer should be very brief. 5.74. What is the difference between the Expenses (% of total expenses) of Compensation of employees in 2008 and the Expenses (% of total expenses) of Subsidies and Transfers in 2012?
Make the answer very short. -52.36. What is the difference between the Expenses (% of total expenses) of Compensation of employees in 2008 and the Expenses (% of total expenses) of Other expenses in 2012?
Your answer should be compact. 15.56. What is the difference between the Expenses (% of total expenses) in Goods and services in 2008 and the Expenses (% of total expenses) in Subsidies and Transfers in 2012?
Offer a terse response. -54.01. What is the difference between the Expenses (% of total expenses) in Goods and services in 2008 and the Expenses (% of total expenses) in Other expenses in 2012?
Offer a very short reply. 13.92. What is the difference between the Expenses (% of total expenses) of Subsidies and Transfers in 2008 and the Expenses (% of total expenses) of Other expenses in 2012?
Offer a terse response. 59.61. What is the difference between the Expenses (% of total expenses) of Compensation of employees in 2009 and the Expenses (% of total expenses) of Goods and services in 2010?
Offer a very short reply. 6.31. What is the difference between the Expenses (% of total expenses) in Compensation of employees in 2009 and the Expenses (% of total expenses) in Subsidies and Transfers in 2010?
Ensure brevity in your answer.  -47.65. What is the difference between the Expenses (% of total expenses) in Compensation of employees in 2009 and the Expenses (% of total expenses) in Other expenses in 2010?
Make the answer very short. 13.37. What is the difference between the Expenses (% of total expenses) of Goods and services in 2009 and the Expenses (% of total expenses) of Subsidies and Transfers in 2010?
Offer a very short reply. -52.64. What is the difference between the Expenses (% of total expenses) of Goods and services in 2009 and the Expenses (% of total expenses) of Other expenses in 2010?
Give a very brief answer. 8.38. What is the difference between the Expenses (% of total expenses) in Subsidies and Transfers in 2009 and the Expenses (% of total expenses) in Other expenses in 2010?
Your answer should be very brief. 59.85. What is the difference between the Expenses (% of total expenses) of Compensation of employees in 2009 and the Expenses (% of total expenses) of Goods and services in 2011?
Your answer should be very brief. 7.09. What is the difference between the Expenses (% of total expenses) of Compensation of employees in 2009 and the Expenses (% of total expenses) of Subsidies and Transfers in 2011?
Provide a succinct answer. -49.11. What is the difference between the Expenses (% of total expenses) in Compensation of employees in 2009 and the Expenses (% of total expenses) in Other expenses in 2011?
Keep it short and to the point. 14.21. What is the difference between the Expenses (% of total expenses) in Goods and services in 2009 and the Expenses (% of total expenses) in Subsidies and Transfers in 2011?
Your answer should be compact. -54.09. What is the difference between the Expenses (% of total expenses) in Goods and services in 2009 and the Expenses (% of total expenses) in Other expenses in 2011?
Make the answer very short. 9.22. What is the difference between the Expenses (% of total expenses) in Subsidies and Transfers in 2009 and the Expenses (% of total expenses) in Other expenses in 2011?
Ensure brevity in your answer.  60.69. What is the difference between the Expenses (% of total expenses) of Compensation of employees in 2009 and the Expenses (% of total expenses) of Goods and services in 2012?
Offer a very short reply. 6.78. What is the difference between the Expenses (% of total expenses) of Compensation of employees in 2009 and the Expenses (% of total expenses) of Subsidies and Transfers in 2012?
Give a very brief answer. -51.33. What is the difference between the Expenses (% of total expenses) of Compensation of employees in 2009 and the Expenses (% of total expenses) of Other expenses in 2012?
Ensure brevity in your answer.  16.6. What is the difference between the Expenses (% of total expenses) of Goods and services in 2009 and the Expenses (% of total expenses) of Subsidies and Transfers in 2012?
Your answer should be compact. -56.31. What is the difference between the Expenses (% of total expenses) of Goods and services in 2009 and the Expenses (% of total expenses) of Other expenses in 2012?
Provide a short and direct response. 11.61. What is the difference between the Expenses (% of total expenses) of Subsidies and Transfers in 2009 and the Expenses (% of total expenses) of Other expenses in 2012?
Your answer should be very brief. 63.08. What is the difference between the Expenses (% of total expenses) of Compensation of employees in 2010 and the Expenses (% of total expenses) of Goods and services in 2011?
Keep it short and to the point. 6.83. What is the difference between the Expenses (% of total expenses) of Compensation of employees in 2010 and the Expenses (% of total expenses) of Subsidies and Transfers in 2011?
Your answer should be compact. -49.37. What is the difference between the Expenses (% of total expenses) in Compensation of employees in 2010 and the Expenses (% of total expenses) in Other expenses in 2011?
Your answer should be very brief. 13.95. What is the difference between the Expenses (% of total expenses) of Goods and services in 2010 and the Expenses (% of total expenses) of Subsidies and Transfers in 2011?
Offer a very short reply. -55.42. What is the difference between the Expenses (% of total expenses) of Goods and services in 2010 and the Expenses (% of total expenses) of Other expenses in 2011?
Provide a succinct answer. 7.9. What is the difference between the Expenses (% of total expenses) in Subsidies and Transfers in 2010 and the Expenses (% of total expenses) in Other expenses in 2011?
Provide a succinct answer. 61.86. What is the difference between the Expenses (% of total expenses) of Compensation of employees in 2010 and the Expenses (% of total expenses) of Goods and services in 2012?
Ensure brevity in your answer.  6.52. What is the difference between the Expenses (% of total expenses) of Compensation of employees in 2010 and the Expenses (% of total expenses) of Subsidies and Transfers in 2012?
Offer a terse response. -51.59. What is the difference between the Expenses (% of total expenses) in Compensation of employees in 2010 and the Expenses (% of total expenses) in Other expenses in 2012?
Make the answer very short. 16.33. What is the difference between the Expenses (% of total expenses) of Goods and services in 2010 and the Expenses (% of total expenses) of Subsidies and Transfers in 2012?
Your response must be concise. -57.64. What is the difference between the Expenses (% of total expenses) of Goods and services in 2010 and the Expenses (% of total expenses) of Other expenses in 2012?
Keep it short and to the point. 10.29. What is the difference between the Expenses (% of total expenses) in Subsidies and Transfers in 2010 and the Expenses (% of total expenses) in Other expenses in 2012?
Give a very brief answer. 64.25. What is the difference between the Expenses (% of total expenses) in Compensation of employees in 2011 and the Expenses (% of total expenses) in Goods and services in 2012?
Your answer should be very brief. 6.52. What is the difference between the Expenses (% of total expenses) in Compensation of employees in 2011 and the Expenses (% of total expenses) in Subsidies and Transfers in 2012?
Provide a short and direct response. -51.59. What is the difference between the Expenses (% of total expenses) in Compensation of employees in 2011 and the Expenses (% of total expenses) in Other expenses in 2012?
Provide a short and direct response. 16.33. What is the difference between the Expenses (% of total expenses) of Goods and services in 2011 and the Expenses (% of total expenses) of Subsidies and Transfers in 2012?
Offer a very short reply. -58.42. What is the difference between the Expenses (% of total expenses) of Goods and services in 2011 and the Expenses (% of total expenses) of Other expenses in 2012?
Give a very brief answer. 9.5. What is the difference between the Expenses (% of total expenses) of Subsidies and Transfers in 2011 and the Expenses (% of total expenses) of Other expenses in 2012?
Your response must be concise. 65.7. What is the average Expenses (% of total expenses) of Compensation of employees per year?
Your response must be concise. 19.96. What is the average Expenses (% of total expenses) of Goods and services per year?
Your answer should be compact. 17.64. What is the average Expenses (% of total expenses) in Subsidies and Transfers per year?
Offer a very short reply. 56.14. What is the average Expenses (% of total expenses) of Other expenses per year?
Your answer should be very brief. 3.65. In the year 2005, what is the difference between the Expenses (% of total expenses) in Compensation of employees and Expenses (% of total expenses) in Goods and services?
Your answer should be very brief. -2.5. In the year 2005, what is the difference between the Expenses (% of total expenses) of Compensation of employees and Expenses (% of total expenses) of Subsidies and Transfers?
Keep it short and to the point. -12.96. In the year 2005, what is the difference between the Expenses (% of total expenses) of Compensation of employees and Expenses (% of total expenses) of Other expenses?
Ensure brevity in your answer.  23.63. In the year 2005, what is the difference between the Expenses (% of total expenses) of Goods and services and Expenses (% of total expenses) of Subsidies and Transfers?
Keep it short and to the point. -10.46. In the year 2005, what is the difference between the Expenses (% of total expenses) of Goods and services and Expenses (% of total expenses) of Other expenses?
Provide a short and direct response. 26.13. In the year 2005, what is the difference between the Expenses (% of total expenses) in Subsidies and Transfers and Expenses (% of total expenses) in Other expenses?
Provide a short and direct response. 36.59. In the year 2006, what is the difference between the Expenses (% of total expenses) in Compensation of employees and Expenses (% of total expenses) in Goods and services?
Your answer should be compact. -2.65. In the year 2006, what is the difference between the Expenses (% of total expenses) in Compensation of employees and Expenses (% of total expenses) in Subsidies and Transfers?
Your answer should be very brief. -18.85. In the year 2006, what is the difference between the Expenses (% of total expenses) in Compensation of employees and Expenses (% of total expenses) in Other expenses?
Offer a terse response. 21.32. In the year 2006, what is the difference between the Expenses (% of total expenses) in Goods and services and Expenses (% of total expenses) in Subsidies and Transfers?
Offer a terse response. -16.2. In the year 2006, what is the difference between the Expenses (% of total expenses) of Goods and services and Expenses (% of total expenses) of Other expenses?
Provide a succinct answer. 23.96. In the year 2006, what is the difference between the Expenses (% of total expenses) in Subsidies and Transfers and Expenses (% of total expenses) in Other expenses?
Your response must be concise. 40.16. In the year 2007, what is the difference between the Expenses (% of total expenses) in Compensation of employees and Expenses (% of total expenses) in Goods and services?
Provide a succinct answer. -1.7. In the year 2007, what is the difference between the Expenses (% of total expenses) in Compensation of employees and Expenses (% of total expenses) in Subsidies and Transfers?
Make the answer very short. -17.6. In the year 2007, what is the difference between the Expenses (% of total expenses) in Compensation of employees and Expenses (% of total expenses) in Other expenses?
Your answer should be very brief. 19.34. In the year 2007, what is the difference between the Expenses (% of total expenses) of Goods and services and Expenses (% of total expenses) of Subsidies and Transfers?
Your answer should be very brief. -15.9. In the year 2007, what is the difference between the Expenses (% of total expenses) of Goods and services and Expenses (% of total expenses) of Other expenses?
Your answer should be very brief. 21.04. In the year 2007, what is the difference between the Expenses (% of total expenses) of Subsidies and Transfers and Expenses (% of total expenses) of Other expenses?
Keep it short and to the point. 36.94. In the year 2008, what is the difference between the Expenses (% of total expenses) in Compensation of employees and Expenses (% of total expenses) in Goods and services?
Offer a terse response. 1.64. In the year 2008, what is the difference between the Expenses (% of total expenses) of Compensation of employees and Expenses (% of total expenses) of Subsidies and Transfers?
Keep it short and to the point. -44.05. In the year 2008, what is the difference between the Expenses (% of total expenses) in Compensation of employees and Expenses (% of total expenses) in Other expenses?
Ensure brevity in your answer.  10.22. In the year 2008, what is the difference between the Expenses (% of total expenses) in Goods and services and Expenses (% of total expenses) in Subsidies and Transfers?
Your answer should be compact. -45.69. In the year 2008, what is the difference between the Expenses (% of total expenses) in Goods and services and Expenses (% of total expenses) in Other expenses?
Your response must be concise. 8.57. In the year 2008, what is the difference between the Expenses (% of total expenses) of Subsidies and Transfers and Expenses (% of total expenses) of Other expenses?
Provide a short and direct response. 54.26. In the year 2009, what is the difference between the Expenses (% of total expenses) of Compensation of employees and Expenses (% of total expenses) of Goods and services?
Your answer should be very brief. 4.99. In the year 2009, what is the difference between the Expenses (% of total expenses) of Compensation of employees and Expenses (% of total expenses) of Subsidies and Transfers?
Your answer should be compact. -46.48. In the year 2009, what is the difference between the Expenses (% of total expenses) of Compensation of employees and Expenses (% of total expenses) of Other expenses?
Ensure brevity in your answer.  13.25. In the year 2009, what is the difference between the Expenses (% of total expenses) of Goods and services and Expenses (% of total expenses) of Subsidies and Transfers?
Your answer should be compact. -51.47. In the year 2009, what is the difference between the Expenses (% of total expenses) of Goods and services and Expenses (% of total expenses) of Other expenses?
Your answer should be very brief. 8.27. In the year 2009, what is the difference between the Expenses (% of total expenses) in Subsidies and Transfers and Expenses (% of total expenses) in Other expenses?
Offer a very short reply. 59.73. In the year 2010, what is the difference between the Expenses (% of total expenses) in Compensation of employees and Expenses (% of total expenses) in Goods and services?
Your response must be concise. 6.05. In the year 2010, what is the difference between the Expenses (% of total expenses) in Compensation of employees and Expenses (% of total expenses) in Subsidies and Transfers?
Ensure brevity in your answer.  -47.92. In the year 2010, what is the difference between the Expenses (% of total expenses) in Compensation of employees and Expenses (% of total expenses) in Other expenses?
Keep it short and to the point. 13.11. In the year 2010, what is the difference between the Expenses (% of total expenses) of Goods and services and Expenses (% of total expenses) of Subsidies and Transfers?
Your answer should be very brief. -53.96. In the year 2010, what is the difference between the Expenses (% of total expenses) in Goods and services and Expenses (% of total expenses) in Other expenses?
Keep it short and to the point. 7.06. In the year 2010, what is the difference between the Expenses (% of total expenses) of Subsidies and Transfers and Expenses (% of total expenses) of Other expenses?
Make the answer very short. 61.02. In the year 2011, what is the difference between the Expenses (% of total expenses) of Compensation of employees and Expenses (% of total expenses) of Goods and services?
Give a very brief answer. 6.83. In the year 2011, what is the difference between the Expenses (% of total expenses) of Compensation of employees and Expenses (% of total expenses) of Subsidies and Transfers?
Provide a short and direct response. -49.37. In the year 2011, what is the difference between the Expenses (% of total expenses) of Compensation of employees and Expenses (% of total expenses) of Other expenses?
Keep it short and to the point. 13.94. In the year 2011, what is the difference between the Expenses (% of total expenses) of Goods and services and Expenses (% of total expenses) of Subsidies and Transfers?
Ensure brevity in your answer.  -56.2. In the year 2011, what is the difference between the Expenses (% of total expenses) of Goods and services and Expenses (% of total expenses) of Other expenses?
Provide a succinct answer. 7.11. In the year 2011, what is the difference between the Expenses (% of total expenses) of Subsidies and Transfers and Expenses (% of total expenses) of Other expenses?
Offer a very short reply. 63.32. In the year 2012, what is the difference between the Expenses (% of total expenses) in Compensation of employees and Expenses (% of total expenses) in Goods and services?
Keep it short and to the point. 5.88. In the year 2012, what is the difference between the Expenses (% of total expenses) in Compensation of employees and Expenses (% of total expenses) in Subsidies and Transfers?
Your answer should be very brief. -52.22. In the year 2012, what is the difference between the Expenses (% of total expenses) in Compensation of employees and Expenses (% of total expenses) in Other expenses?
Your response must be concise. 15.7. In the year 2012, what is the difference between the Expenses (% of total expenses) in Goods and services and Expenses (% of total expenses) in Subsidies and Transfers?
Offer a terse response. -58.11. In the year 2012, what is the difference between the Expenses (% of total expenses) of Goods and services and Expenses (% of total expenses) of Other expenses?
Ensure brevity in your answer.  9.82. In the year 2012, what is the difference between the Expenses (% of total expenses) in Subsidies and Transfers and Expenses (% of total expenses) in Other expenses?
Provide a succinct answer. 67.92. What is the ratio of the Expenses (% of total expenses) of Compensation of employees in 2005 to that in 2006?
Provide a succinct answer. 1.09. What is the ratio of the Expenses (% of total expenses) of Goods and services in 2005 to that in 2006?
Your answer should be compact. 1.07. What is the ratio of the Expenses (% of total expenses) of Subsidies and Transfers in 2005 to that in 2006?
Offer a terse response. 0.91. What is the ratio of the Expenses (% of total expenses) in Other expenses in 2005 to that in 2006?
Offer a terse response. 0.94. What is the ratio of the Expenses (% of total expenses) of Compensation of employees in 2005 to that in 2007?
Your answer should be very brief. 1.08. What is the ratio of the Expenses (% of total expenses) in Goods and services in 2005 to that in 2007?
Your answer should be very brief. 1.11. What is the ratio of the Expenses (% of total expenses) of Subsidies and Transfers in 2005 to that in 2007?
Ensure brevity in your answer.  0.94. What is the ratio of the Expenses (% of total expenses) in Other expenses in 2005 to that in 2007?
Ensure brevity in your answer.  0.54. What is the ratio of the Expenses (% of total expenses) of Compensation of employees in 2005 to that in 2008?
Offer a very short reply. 1.6. What is the ratio of the Expenses (% of total expenses) of Goods and services in 2005 to that in 2008?
Ensure brevity in your answer.  1.95. What is the ratio of the Expenses (% of total expenses) in Subsidies and Transfers in 2005 to that in 2008?
Your response must be concise. 0.65. What is the ratio of the Expenses (% of total expenses) of Other expenses in 2005 to that in 2008?
Make the answer very short. 0.43. What is the ratio of the Expenses (% of total expenses) of Compensation of employees in 2005 to that in 2009?
Offer a terse response. 1.51. What is the ratio of the Expenses (% of total expenses) in Goods and services in 2005 to that in 2009?
Make the answer very short. 2.31. What is the ratio of the Expenses (% of total expenses) of Subsidies and Transfers in 2005 to that in 2009?
Make the answer very short. 0.61. What is the ratio of the Expenses (% of total expenses) in Other expenses in 2005 to that in 2009?
Give a very brief answer. 0.63. What is the ratio of the Expenses (% of total expenses) of Compensation of employees in 2005 to that in 2010?
Your answer should be compact. 1.53. What is the ratio of the Expenses (% of total expenses) in Goods and services in 2005 to that in 2010?
Ensure brevity in your answer.  2.58. What is the ratio of the Expenses (% of total expenses) in Subsidies and Transfers in 2005 to that in 2010?
Keep it short and to the point. 0.6. What is the ratio of the Expenses (% of total expenses) in Other expenses in 2005 to that in 2010?
Provide a succinct answer. 0.65. What is the ratio of the Expenses (% of total expenses) of Compensation of employees in 2005 to that in 2011?
Your response must be concise. 1.53. What is the ratio of the Expenses (% of total expenses) of Goods and services in 2005 to that in 2011?
Provide a succinct answer. 2.78. What is the ratio of the Expenses (% of total expenses) of Subsidies and Transfers in 2005 to that in 2011?
Keep it short and to the point. 0.59. What is the ratio of the Expenses (% of total expenses) of Other expenses in 2005 to that in 2011?
Offer a very short reply. 0.82. What is the ratio of the Expenses (% of total expenses) of Compensation of employees in 2005 to that in 2012?
Your response must be concise. 1.59. What is the ratio of the Expenses (% of total expenses) in Goods and services in 2005 to that in 2012?
Offer a terse response. 2.7. What is the ratio of the Expenses (% of total expenses) of Subsidies and Transfers in 2005 to that in 2012?
Provide a succinct answer. 0.57. What is the ratio of the Expenses (% of total expenses) in Other expenses in 2005 to that in 2012?
Your answer should be compact. 3.07. What is the ratio of the Expenses (% of total expenses) of Compensation of employees in 2006 to that in 2007?
Provide a short and direct response. 0.99. What is the ratio of the Expenses (% of total expenses) in Goods and services in 2006 to that in 2007?
Give a very brief answer. 1.03. What is the ratio of the Expenses (% of total expenses) of Subsidies and Transfers in 2006 to that in 2007?
Your answer should be very brief. 1.03. What is the ratio of the Expenses (% of total expenses) in Other expenses in 2006 to that in 2007?
Offer a terse response. 0.57. What is the ratio of the Expenses (% of total expenses) of Compensation of employees in 2006 to that in 2008?
Your answer should be very brief. 1.47. What is the ratio of the Expenses (% of total expenses) in Goods and services in 2006 to that in 2008?
Give a very brief answer. 1.81. What is the ratio of the Expenses (% of total expenses) in Subsidies and Transfers in 2006 to that in 2008?
Your answer should be very brief. 0.71. What is the ratio of the Expenses (% of total expenses) of Other expenses in 2006 to that in 2008?
Keep it short and to the point. 0.46. What is the ratio of the Expenses (% of total expenses) in Compensation of employees in 2006 to that in 2009?
Ensure brevity in your answer.  1.38. What is the ratio of the Expenses (% of total expenses) of Goods and services in 2006 to that in 2009?
Give a very brief answer. 2.15. What is the ratio of the Expenses (% of total expenses) of Subsidies and Transfers in 2006 to that in 2009?
Keep it short and to the point. 0.67. What is the ratio of the Expenses (% of total expenses) of Other expenses in 2006 to that in 2009?
Offer a terse response. 0.68. What is the ratio of the Expenses (% of total expenses) of Compensation of employees in 2006 to that in 2010?
Provide a succinct answer. 1.4. What is the ratio of the Expenses (% of total expenses) in Goods and services in 2006 to that in 2010?
Offer a terse response. 2.4. What is the ratio of the Expenses (% of total expenses) in Subsidies and Transfers in 2006 to that in 2010?
Provide a succinct answer. 0.66. What is the ratio of the Expenses (% of total expenses) of Other expenses in 2006 to that in 2010?
Your answer should be very brief. 0.69. What is the ratio of the Expenses (% of total expenses) in Compensation of employees in 2006 to that in 2011?
Provide a succinct answer. 1.4. What is the ratio of the Expenses (% of total expenses) of Goods and services in 2006 to that in 2011?
Keep it short and to the point. 2.58. What is the ratio of the Expenses (% of total expenses) of Subsidies and Transfers in 2006 to that in 2011?
Make the answer very short. 0.65. What is the ratio of the Expenses (% of total expenses) of Other expenses in 2006 to that in 2011?
Your response must be concise. 0.87. What is the ratio of the Expenses (% of total expenses) in Compensation of employees in 2006 to that in 2012?
Ensure brevity in your answer.  1.46. What is the ratio of the Expenses (% of total expenses) of Goods and services in 2006 to that in 2012?
Your response must be concise. 2.51. What is the ratio of the Expenses (% of total expenses) in Subsidies and Transfers in 2006 to that in 2012?
Provide a short and direct response. 0.63. What is the ratio of the Expenses (% of total expenses) in Other expenses in 2006 to that in 2012?
Provide a short and direct response. 3.26. What is the ratio of the Expenses (% of total expenses) in Compensation of employees in 2007 to that in 2008?
Keep it short and to the point. 1.48. What is the ratio of the Expenses (% of total expenses) of Goods and services in 2007 to that in 2008?
Your answer should be very brief. 1.76. What is the ratio of the Expenses (% of total expenses) of Subsidies and Transfers in 2007 to that in 2008?
Make the answer very short. 0.69. What is the ratio of the Expenses (% of total expenses) of Other expenses in 2007 to that in 2008?
Offer a very short reply. 0.81. What is the ratio of the Expenses (% of total expenses) in Compensation of employees in 2007 to that in 2009?
Offer a terse response. 1.39. What is the ratio of the Expenses (% of total expenses) of Goods and services in 2007 to that in 2009?
Keep it short and to the point. 2.09. What is the ratio of the Expenses (% of total expenses) of Subsidies and Transfers in 2007 to that in 2009?
Your response must be concise. 0.66. What is the ratio of the Expenses (% of total expenses) of Other expenses in 2007 to that in 2009?
Give a very brief answer. 1.19. What is the ratio of the Expenses (% of total expenses) of Compensation of employees in 2007 to that in 2010?
Give a very brief answer. 1.41. What is the ratio of the Expenses (% of total expenses) in Goods and services in 2007 to that in 2010?
Give a very brief answer. 2.33. What is the ratio of the Expenses (% of total expenses) in Subsidies and Transfers in 2007 to that in 2010?
Offer a very short reply. 0.64. What is the ratio of the Expenses (% of total expenses) in Other expenses in 2007 to that in 2010?
Your response must be concise. 1.22. What is the ratio of the Expenses (% of total expenses) in Compensation of employees in 2007 to that in 2011?
Your answer should be very brief. 1.41. What is the ratio of the Expenses (% of total expenses) of Goods and services in 2007 to that in 2011?
Your answer should be compact. 2.51. What is the ratio of the Expenses (% of total expenses) of Subsidies and Transfers in 2007 to that in 2011?
Offer a terse response. 0.63. What is the ratio of the Expenses (% of total expenses) in Other expenses in 2007 to that in 2011?
Your response must be concise. 1.53. What is the ratio of the Expenses (% of total expenses) in Compensation of employees in 2007 to that in 2012?
Your response must be concise. 1.47. What is the ratio of the Expenses (% of total expenses) in Goods and services in 2007 to that in 2012?
Offer a very short reply. 2.44. What is the ratio of the Expenses (% of total expenses) in Subsidies and Transfers in 2007 to that in 2012?
Your answer should be compact. 0.61. What is the ratio of the Expenses (% of total expenses) of Other expenses in 2007 to that in 2012?
Your answer should be compact. 5.74. What is the ratio of the Expenses (% of total expenses) of Compensation of employees in 2008 to that in 2009?
Make the answer very short. 0.94. What is the ratio of the Expenses (% of total expenses) of Goods and services in 2008 to that in 2009?
Offer a terse response. 1.18. What is the ratio of the Expenses (% of total expenses) of Subsidies and Transfers in 2008 to that in 2009?
Provide a short and direct response. 0.95. What is the ratio of the Expenses (% of total expenses) in Other expenses in 2008 to that in 2009?
Provide a short and direct response. 1.47. What is the ratio of the Expenses (% of total expenses) of Compensation of employees in 2008 to that in 2010?
Offer a very short reply. 0.95. What is the ratio of the Expenses (% of total expenses) of Goods and services in 2008 to that in 2010?
Your answer should be very brief. 1.33. What is the ratio of the Expenses (% of total expenses) of Subsidies and Transfers in 2008 to that in 2010?
Your answer should be compact. 0.93. What is the ratio of the Expenses (% of total expenses) in Other expenses in 2008 to that in 2010?
Your answer should be very brief. 1.52. What is the ratio of the Expenses (% of total expenses) of Compensation of employees in 2008 to that in 2011?
Make the answer very short. 0.95. What is the ratio of the Expenses (% of total expenses) in Goods and services in 2008 to that in 2011?
Offer a very short reply. 1.43. What is the ratio of the Expenses (% of total expenses) in Subsidies and Transfers in 2008 to that in 2011?
Your answer should be compact. 0.91. What is the ratio of the Expenses (% of total expenses) of Other expenses in 2008 to that in 2011?
Your answer should be very brief. 1.91. What is the ratio of the Expenses (% of total expenses) of Goods and services in 2008 to that in 2012?
Offer a very short reply. 1.38. What is the ratio of the Expenses (% of total expenses) of Subsidies and Transfers in 2008 to that in 2012?
Your answer should be very brief. 0.88. What is the ratio of the Expenses (% of total expenses) of Other expenses in 2008 to that in 2012?
Offer a terse response. 7.12. What is the ratio of the Expenses (% of total expenses) in Compensation of employees in 2009 to that in 2010?
Your answer should be compact. 1.02. What is the ratio of the Expenses (% of total expenses) of Goods and services in 2009 to that in 2010?
Provide a short and direct response. 1.12. What is the ratio of the Expenses (% of total expenses) of Other expenses in 2009 to that in 2010?
Give a very brief answer. 1.03. What is the ratio of the Expenses (% of total expenses) of Compensation of employees in 2009 to that in 2011?
Your answer should be very brief. 1.02. What is the ratio of the Expenses (% of total expenses) of Goods and services in 2009 to that in 2011?
Your answer should be very brief. 1.2. What is the ratio of the Expenses (% of total expenses) in Subsidies and Transfers in 2009 to that in 2011?
Keep it short and to the point. 0.96. What is the ratio of the Expenses (% of total expenses) of Other expenses in 2009 to that in 2011?
Give a very brief answer. 1.29. What is the ratio of the Expenses (% of total expenses) of Compensation of employees in 2009 to that in 2012?
Keep it short and to the point. 1.05. What is the ratio of the Expenses (% of total expenses) in Goods and services in 2009 to that in 2012?
Give a very brief answer. 1.17. What is the ratio of the Expenses (% of total expenses) of Subsidies and Transfers in 2009 to that in 2012?
Provide a succinct answer. 0.93. What is the ratio of the Expenses (% of total expenses) in Other expenses in 2009 to that in 2012?
Offer a very short reply. 4.83. What is the ratio of the Expenses (% of total expenses) in Compensation of employees in 2010 to that in 2011?
Offer a terse response. 1. What is the ratio of the Expenses (% of total expenses) in Goods and services in 2010 to that in 2011?
Ensure brevity in your answer.  1.08. What is the ratio of the Expenses (% of total expenses) in Subsidies and Transfers in 2010 to that in 2011?
Your answer should be very brief. 0.98. What is the ratio of the Expenses (% of total expenses) of Other expenses in 2010 to that in 2011?
Keep it short and to the point. 1.26. What is the ratio of the Expenses (% of total expenses) in Goods and services in 2010 to that in 2012?
Your answer should be compact. 1.04. What is the ratio of the Expenses (% of total expenses) in Subsidies and Transfers in 2010 to that in 2012?
Provide a short and direct response. 0.95. What is the ratio of the Expenses (% of total expenses) of Other expenses in 2010 to that in 2012?
Your response must be concise. 4.7. What is the ratio of the Expenses (% of total expenses) of Compensation of employees in 2011 to that in 2012?
Ensure brevity in your answer.  1.04. What is the ratio of the Expenses (% of total expenses) in Goods and services in 2011 to that in 2012?
Your answer should be compact. 0.97. What is the ratio of the Expenses (% of total expenses) of Subsidies and Transfers in 2011 to that in 2012?
Make the answer very short. 0.97. What is the ratio of the Expenses (% of total expenses) of Other expenses in 2011 to that in 2012?
Give a very brief answer. 3.74. What is the difference between the highest and the second highest Expenses (% of total expenses) in Compensation of employees?
Your response must be concise. 1.97. What is the difference between the highest and the second highest Expenses (% of total expenses) in Goods and services?
Your response must be concise. 2. What is the difference between the highest and the second highest Expenses (% of total expenses) of Subsidies and Transfers?
Keep it short and to the point. 2.22. What is the difference between the highest and the second highest Expenses (% of total expenses) of Other expenses?
Give a very brief answer. 1.21. What is the difference between the highest and the lowest Expenses (% of total expenses) of Compensation of employees?
Offer a terse response. 9.88. What is the difference between the highest and the lowest Expenses (% of total expenses) in Goods and services?
Your answer should be compact. 18.43. What is the difference between the highest and the lowest Expenses (% of total expenses) of Subsidies and Transfers?
Make the answer very short. 29.53. What is the difference between the highest and the lowest Expenses (% of total expenses) in Other expenses?
Your answer should be very brief. 5.34. 